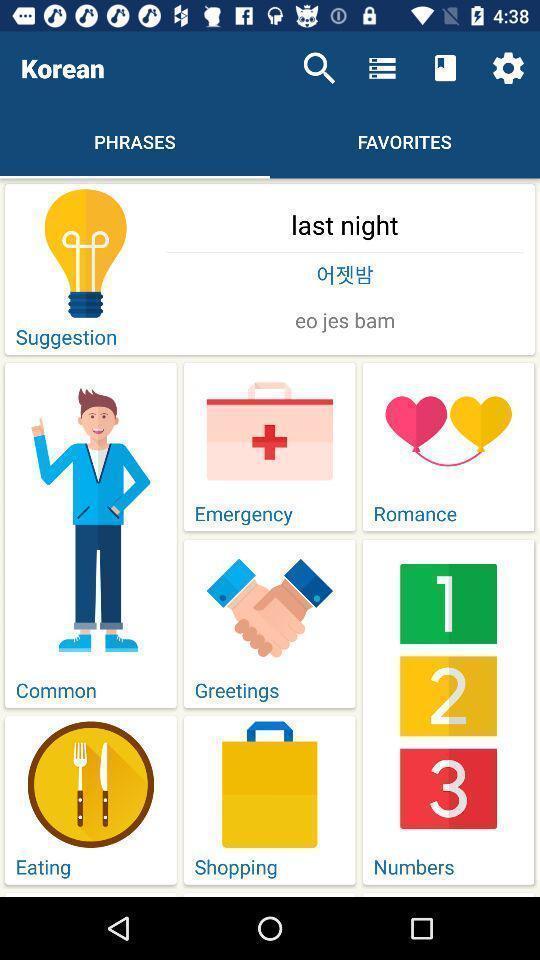Please provide a description for this image. Screen displaying multiple topics in a language learning application. 